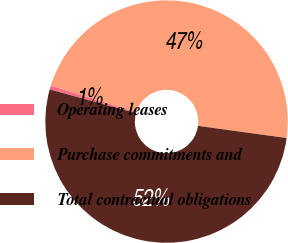Convert chart. <chart><loc_0><loc_0><loc_500><loc_500><pie_chart><fcel>Operating leases<fcel>Purchase commitments and<fcel>Total contractual obligations<nl><fcel>0.53%<fcel>47.37%<fcel>52.1%<nl></chart> 